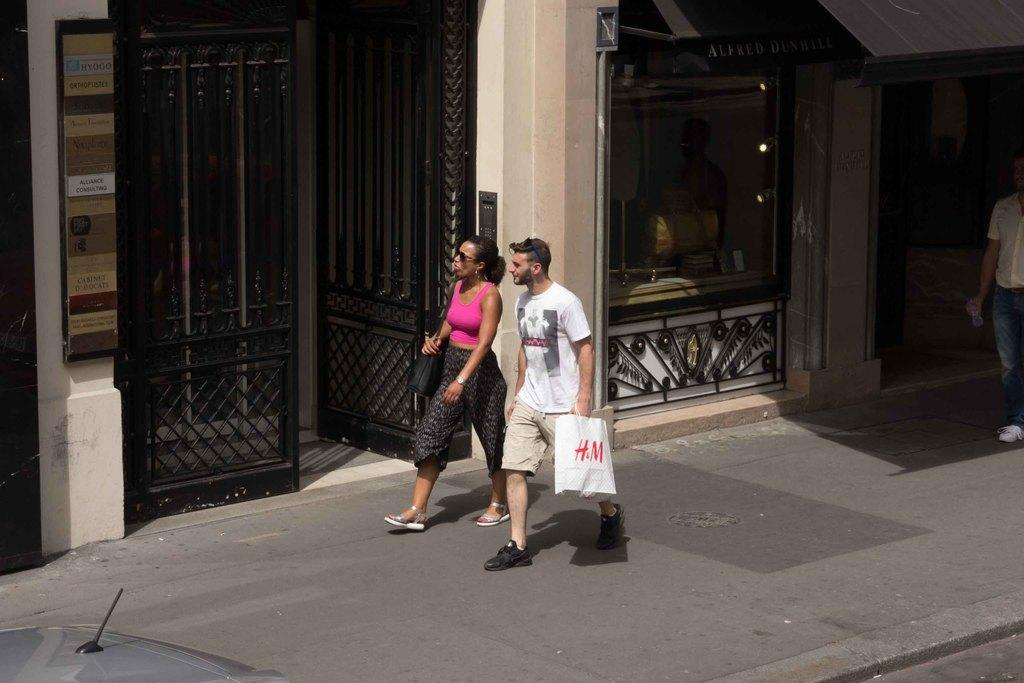How many people are present in the image? There are two people, a man and a woman, present in the image. What are the man and woman doing in the image? The man and woman are walking on the road. What is the man holding in his hand? The man is holding a bag with his hand. What can be seen in the background of the image? There is a building, lights, boards, gates, and a person in the background of the image. What type of net can be seen in the image? There is no net present in the image. What event is taking place in the image? There is no specific event mentioned or depicted in the image. 